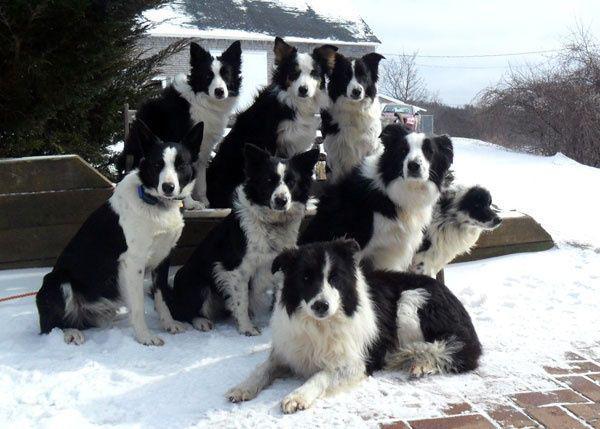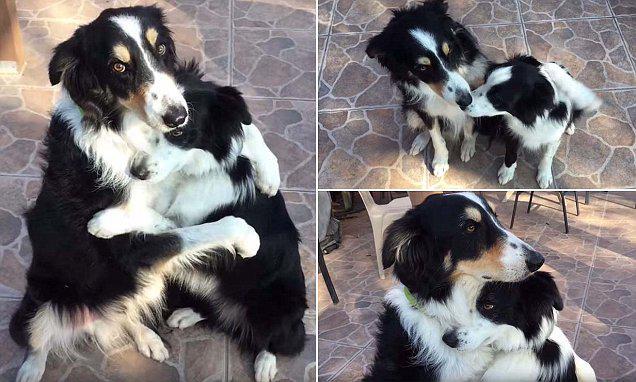The first image is the image on the left, the second image is the image on the right. For the images displayed, is the sentence "The right image contains only one human and one dog." factually correct? Answer yes or no. No. The first image is the image on the left, the second image is the image on the right. Given the left and right images, does the statement "An image shows a long-haired man in jeans crouching behind a black-and-white dog." hold true? Answer yes or no. No. 